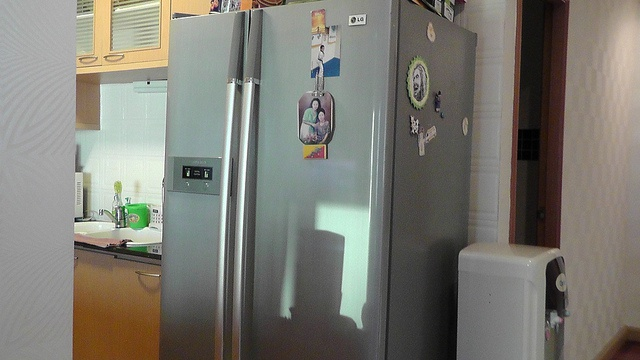Describe the objects in this image and their specific colors. I can see refrigerator in darkgray, gray, and black tones, sink in darkgray, beige, and gray tones, people in darkgray, gray, and black tones, cup in darkgray, lightgreen, and green tones, and people in darkgray, gray, and black tones in this image. 